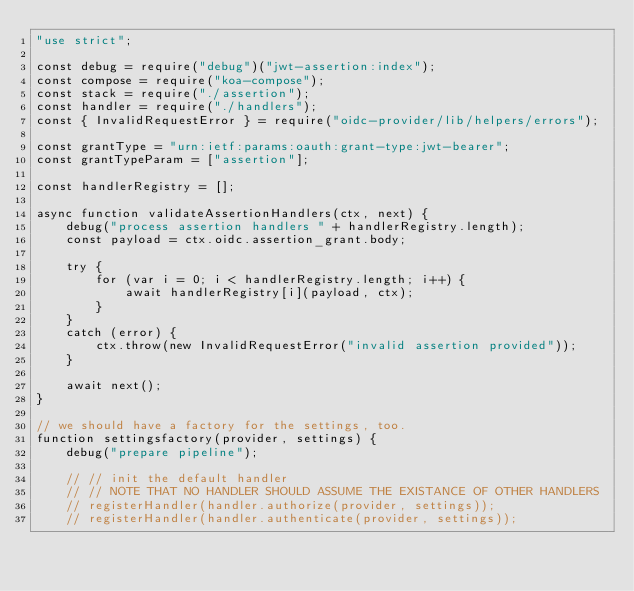Convert code to text. <code><loc_0><loc_0><loc_500><loc_500><_JavaScript_>"use strict";

const debug = require("debug")("jwt-assertion:index");
const compose = require("koa-compose");
const stack = require("./assertion");
const handler = require("./handlers");
const { InvalidRequestError } = require("oidc-provider/lib/helpers/errors");

const grantType = "urn:ietf:params:oauth:grant-type:jwt-bearer";
const grantTypeParam = ["assertion"];

const handlerRegistry = [];

async function validateAssertionHandlers(ctx, next) {
    debug("process assertion handlers " + handlerRegistry.length);
    const payload = ctx.oidc.assertion_grant.body;

    try {
        for (var i = 0; i < handlerRegistry.length; i++) {
            await handlerRegistry[i](payload, ctx);
        }
    }
    catch (error) {
        ctx.throw(new InvalidRequestError("invalid assertion provided"));
    }

    await next();
}

// we should have a factory for the settings, too.
function settingsfactory(provider, settings) {
    debug("prepare pipeline");

    // // init the default handler
    // // NOTE THAT NO HANDLER SHOULD ASSUME THE EXISTANCE OF OTHER HANDLERS
    // registerHandler(handler.authorize(provider, settings));
    // registerHandler(handler.authenticate(provider, settings));
</code> 